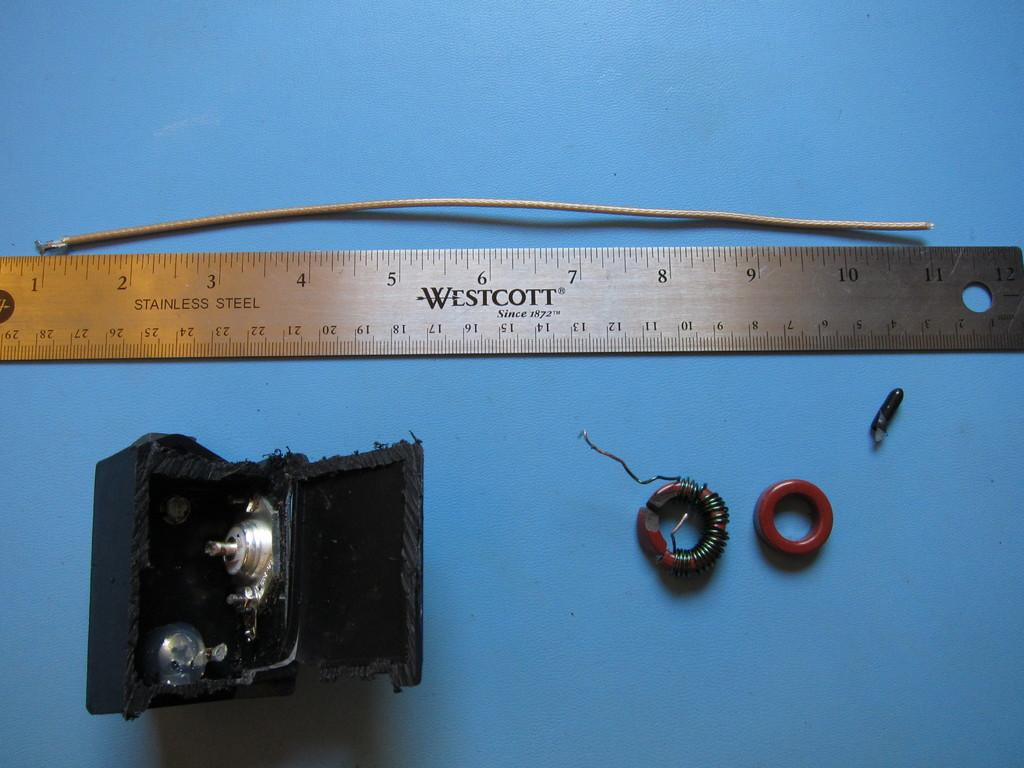<image>
Summarize the visual content of the image. Wire rings are on a table beneath a Westcott ruler. 